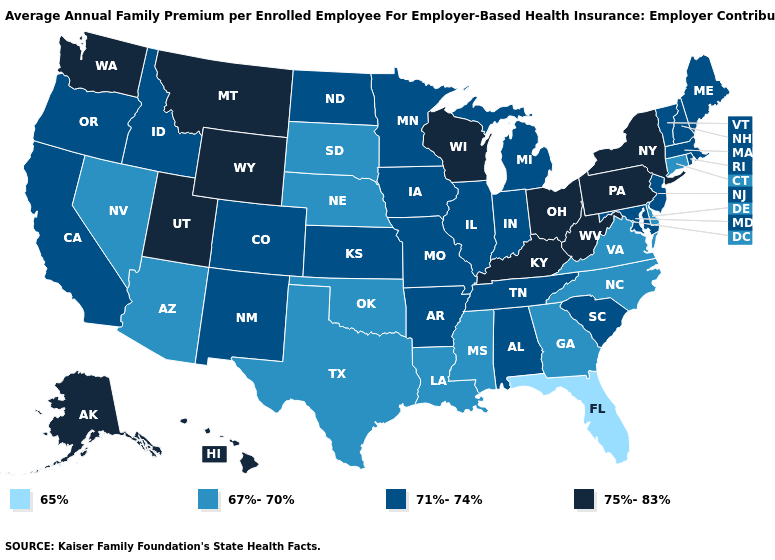What is the value of Kansas?
Give a very brief answer. 71%-74%. Which states have the lowest value in the USA?
Concise answer only. Florida. What is the value of Alabama?
Quick response, please. 71%-74%. Name the states that have a value in the range 75%-83%?
Answer briefly. Alaska, Hawaii, Kentucky, Montana, New York, Ohio, Pennsylvania, Utah, Washington, West Virginia, Wisconsin, Wyoming. Which states have the lowest value in the USA?
Be succinct. Florida. What is the value of Kentucky?
Give a very brief answer. 75%-83%. Is the legend a continuous bar?
Keep it brief. No. What is the lowest value in the Northeast?
Short answer required. 67%-70%. Does the map have missing data?
Write a very short answer. No. Name the states that have a value in the range 75%-83%?
Write a very short answer. Alaska, Hawaii, Kentucky, Montana, New York, Ohio, Pennsylvania, Utah, Washington, West Virginia, Wisconsin, Wyoming. What is the value of South Carolina?
Give a very brief answer. 71%-74%. Among the states that border Massachusetts , which have the lowest value?
Quick response, please. Connecticut. Among the states that border West Virginia , which have the highest value?
Concise answer only. Kentucky, Ohio, Pennsylvania. How many symbols are there in the legend?
Short answer required. 4. Among the states that border South Dakota , does Wyoming have the lowest value?
Concise answer only. No. 